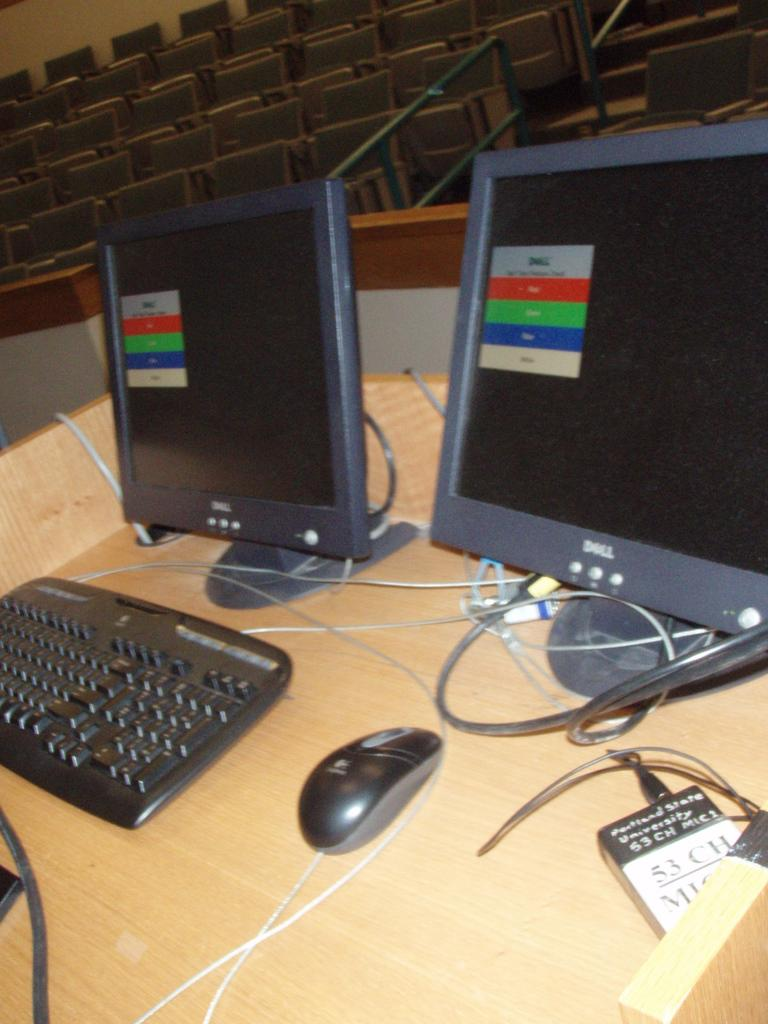<image>
Summarize the visual content of the image. two computers are sitting at a desk and there is a university tag there as well 